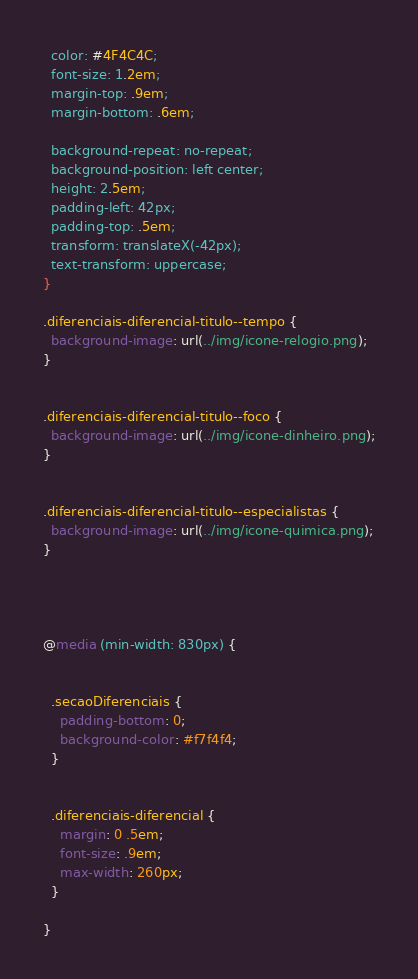<code> <loc_0><loc_0><loc_500><loc_500><_CSS_>  color: #4F4C4C;
  font-size: 1.2em;
  margin-top: .9em;
  margin-bottom: .6em;

  background-repeat: no-repeat;
  background-position: left center;
  height: 2.5em;
  padding-left: 42px;
  padding-top: .5em;
  transform: translateX(-42px);
  text-transform: uppercase;
}

.diferenciais-diferencial-titulo--tempo {
  background-image: url(../img/icone-relogio.png);
}


.diferenciais-diferencial-titulo--foco {
  background-image: url(../img/icone-dinheiro.png);
}


.diferenciais-diferencial-titulo--especialistas {
  background-image: url(../img/icone-quimica.png);
}




@media (min-width: 830px) {


  .secaoDiferenciais {
    padding-bottom: 0;
    background-color: #f7f4f4;
  }


  .diferenciais-diferencial {
    margin: 0 .5em;
    font-size: .9em;
    max-width: 260px;
  }

}
</code> 